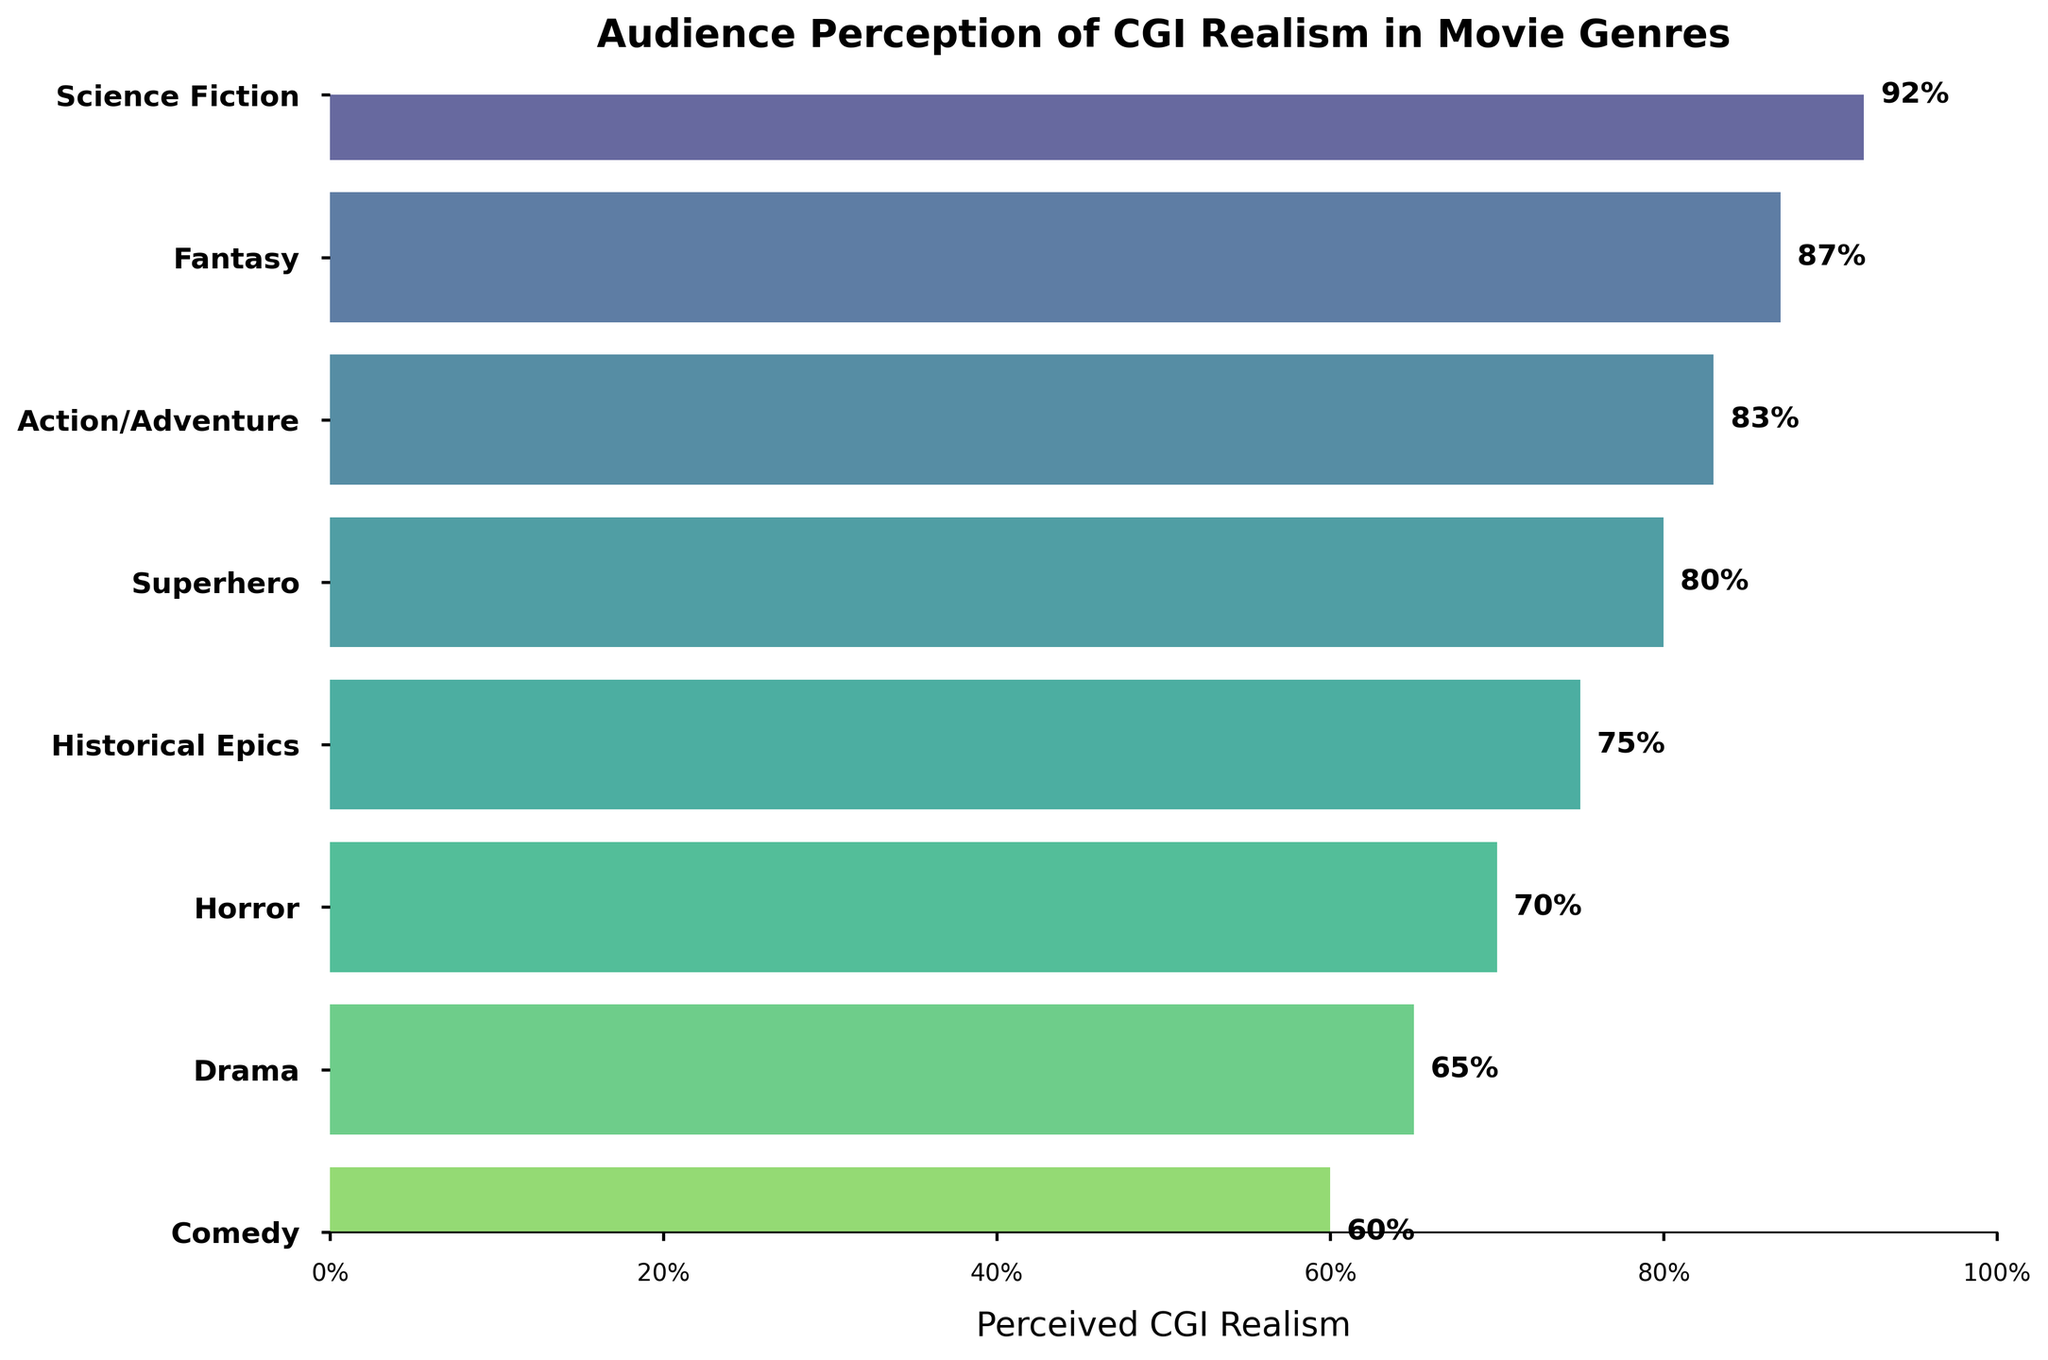How many genres are there in the chart? Count the number of labeled elements on the y-axis. There are 8 genres listed.
Answer: 8 Which genre has the highest perceived CGI realism? Locate the highest value on the x-axis and find its corresponding genre on the y-axis. Science Fiction has the highest perceived CGI realism with 92%.
Answer: Science Fiction What is the perceived CGI realism for Comedy? Find the Comedy genre on the y-axis and refer to the corresponding value on the x-axis. The perceived CGI realism for Comedy is 60%.
Answer: 60% What is the difference in perceived CGI realism between Science Fiction and Horror? Identify the values for Science Fiction (92%) and Horror (70%). Subtract the two values: 92% - 70% = 22%.
Answer: 22% What is the average perceived CGI realism across all genres? Sum all the percentages: 92 + 87 + 83 + 80 + 75 + 70 + 65 + 60 = 612. Divide by the number of genres (8): 612 / 8 = 76.5%.
Answer: 76.5% Which genres have a perceived CGI realism greater than 80%? Identify all genres with values greater than 80% on the x-axis. They are Science Fiction (92%), Fantasy (87%), and Action/Adventure (83%).
Answer: Science Fiction, Fantasy, Action/Adventure Is the perceived CGI realism generally higher in action-heavy genres than in non-action genres? Compare the values of action-heavy genres (Science Fiction, Action/Adventure, Superhero) with non-action genres (Historical Epics, Horror, Drama, Comedy). Action-heavy genres have higher values overall.
Answer: Yes Which genre has the lowest perceived CGI realism and what is its value? Identify the lowest value on the x-axis and find its corresponding genre on the y-axis. Comedy has the lowest perceived CGI realism with 60%.
Answer: Comedy, 60% What is the cumulative percentage of perceived CGI realism for Science Fiction, Fantasy, and Action/Adventure? Sum the percentages of these three genres: 92 + 87 + 83 = 262%.
Answer: 262% How does the perceived CGI realism of Superhero compare to that of Drama? Identify the values for Superhero (80%) and Drama (65%). Superhero has a higher perceived CGI realism.
Answer: Superhero is higher 